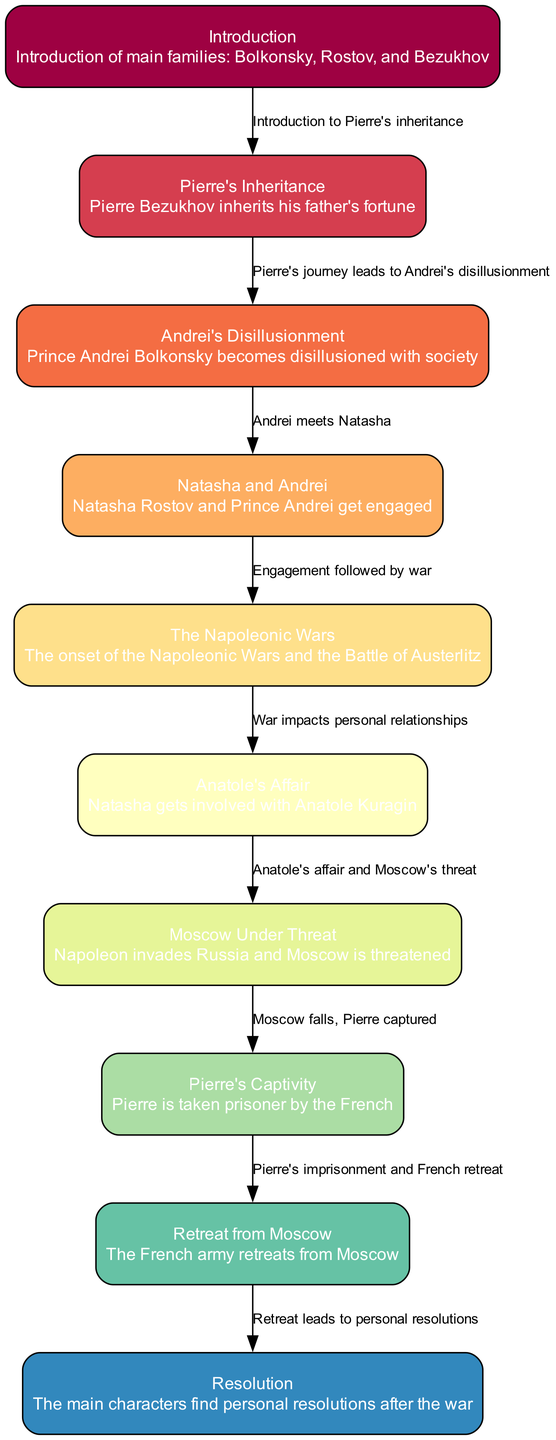What is the first milestone in the plot evolution of 'War and Peace'? The first milestone according to the flowchart is labeled "Introduction" where the main families are introduced. This is the starting point of the plot development.
Answer: Introduction How many nodes are present in the flowchart? By counting each distinct milestone node, we find there are a total of 10 nodes in the flowchart, each representing a significant event in the plot.
Answer: 10 What follows Pierre's Inheritance? The edge from Pierre's Inheritance leads directly to "Andrei's Disillusionment," indicating that this event follows directly after Pierre's inheritance of his father's fortune.
Answer: Andrei's Disillusionment What is the relationship between "Moscow Under Threat" and "Pierre's Captivity"? According to the edges, "Moscow Under Threat" leads to "Pierre's Captivity." This means that the threat to Moscow is a causal element leading to Pierre being taken prisoner by the French.
Answer: Moscow Under Threat leads to Pierre's Captivity What event does the military conflict lead to after "Retreat from Moscow"? The edge that goes from "Retreat from Moscow" directly leads to the final resolution where the main characters find personal resolutions after the war, illustrating that this military retreat concludes with personal resolutions.
Answer: Resolution How many edges are there connecting the nodes? By reviewing the connections between the nodes, we determine there are 9 edges, each representing a transition from one significant event to another in the plot.
Answer: 9 What major event occurs after Natasha and Andrei get engaged? "Natasha and Andrei" corresponds to the next node indicating that the engagement is followed by the onset of "The Napoleonic Wars." This illustrates a key shift from personal events to larger societal issues.
Answer: The Napoleonic Wars Which character's experience is tied to Anatole's affair? The relationship is depicted through the edge leading from "Anatole's Affair" to "Moscow Under Threat," indicating that Natasha's involvement with Anatole directly correlates with the impending threat to Moscow.
Answer: Natasha What is indicated by the edge from "Pierre's Captivity" to "Retreat from Moscow"? This edge indicates a sequence where Pierre's imprisonment is followed by the French army's retreat, suggesting that Pierre's experience is directly tied to the military events occurring in the story.
Answer: Pierre's Captivity leads to Retreat from Moscow 